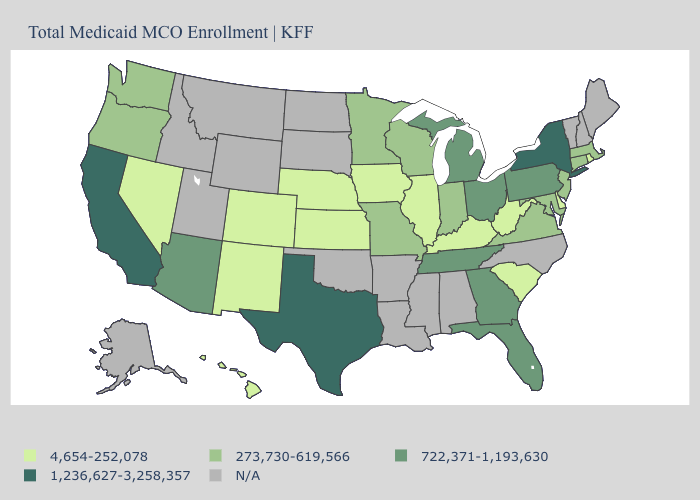Does Missouri have the highest value in the MidWest?
Write a very short answer. No. What is the value of Virginia?
Quick response, please. 273,730-619,566. What is the value of Massachusetts?
Quick response, please. 273,730-619,566. Which states hav the highest value in the Northeast?
Keep it brief. New York. Which states have the lowest value in the USA?
Short answer required. Colorado, Delaware, Hawaii, Illinois, Iowa, Kansas, Kentucky, Nebraska, Nevada, New Mexico, Rhode Island, South Carolina, West Virginia. What is the lowest value in the USA?
Short answer required. 4,654-252,078. How many symbols are there in the legend?
Answer briefly. 5. What is the value of Idaho?
Keep it brief. N/A. Does Wisconsin have the lowest value in the MidWest?
Be succinct. No. What is the lowest value in states that border Oklahoma?
Give a very brief answer. 4,654-252,078. Name the states that have a value in the range 273,730-619,566?
Keep it brief. Connecticut, Indiana, Maryland, Massachusetts, Minnesota, Missouri, New Jersey, Oregon, Virginia, Washington, Wisconsin. What is the value of Massachusetts?
Quick response, please. 273,730-619,566. What is the value of New York?
Be succinct. 1,236,627-3,258,357. What is the value of California?
Give a very brief answer. 1,236,627-3,258,357. How many symbols are there in the legend?
Concise answer only. 5. 